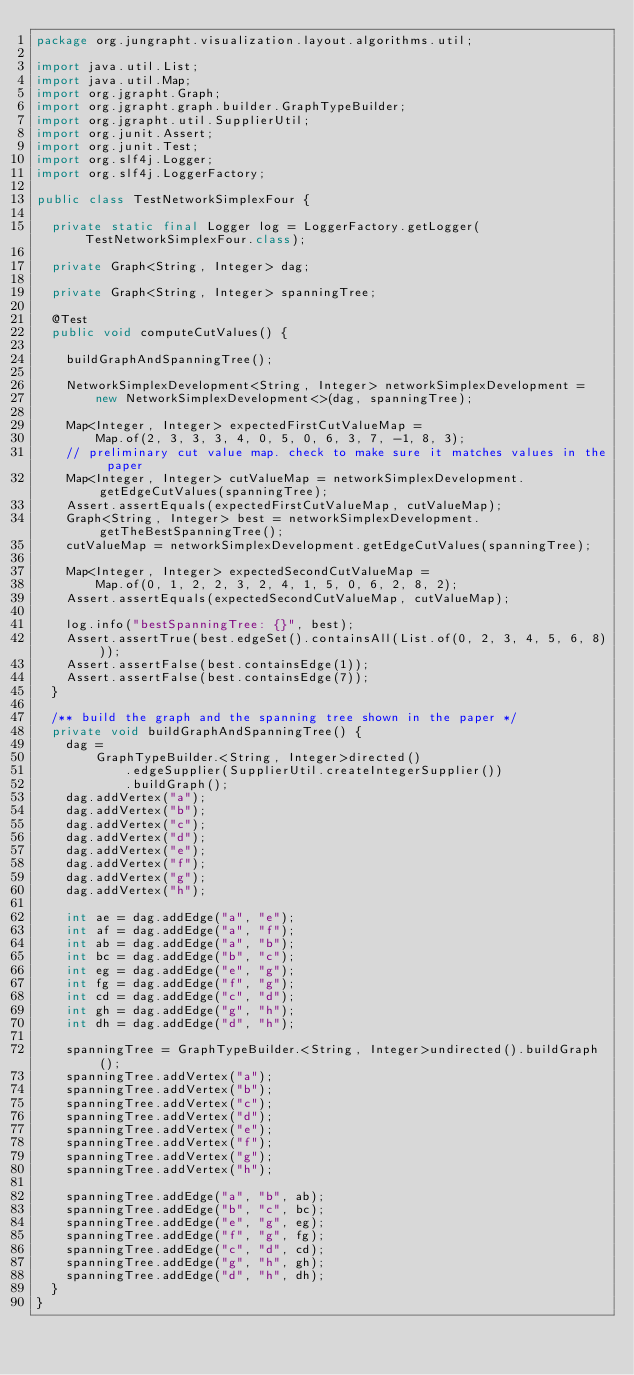Convert code to text. <code><loc_0><loc_0><loc_500><loc_500><_Java_>package org.jungrapht.visualization.layout.algorithms.util;

import java.util.List;
import java.util.Map;
import org.jgrapht.Graph;
import org.jgrapht.graph.builder.GraphTypeBuilder;
import org.jgrapht.util.SupplierUtil;
import org.junit.Assert;
import org.junit.Test;
import org.slf4j.Logger;
import org.slf4j.LoggerFactory;

public class TestNetworkSimplexFour {

  private static final Logger log = LoggerFactory.getLogger(TestNetworkSimplexFour.class);

  private Graph<String, Integer> dag;

  private Graph<String, Integer> spanningTree;

  @Test
  public void computeCutValues() {

    buildGraphAndSpanningTree();

    NetworkSimplexDevelopment<String, Integer> networkSimplexDevelopment =
        new NetworkSimplexDevelopment<>(dag, spanningTree);

    Map<Integer, Integer> expectedFirstCutValueMap =
        Map.of(2, 3, 3, 3, 4, 0, 5, 0, 6, 3, 7, -1, 8, 3);
    // preliminary cut value map. check to make sure it matches values in the paper
    Map<Integer, Integer> cutValueMap = networkSimplexDevelopment.getEdgeCutValues(spanningTree);
    Assert.assertEquals(expectedFirstCutValueMap, cutValueMap);
    Graph<String, Integer> best = networkSimplexDevelopment.getTheBestSpanningTree();
    cutValueMap = networkSimplexDevelopment.getEdgeCutValues(spanningTree);

    Map<Integer, Integer> expectedSecondCutValueMap =
        Map.of(0, 1, 2, 2, 3, 2, 4, 1, 5, 0, 6, 2, 8, 2);
    Assert.assertEquals(expectedSecondCutValueMap, cutValueMap);

    log.info("bestSpanningTree: {}", best);
    Assert.assertTrue(best.edgeSet().containsAll(List.of(0, 2, 3, 4, 5, 6, 8)));
    Assert.assertFalse(best.containsEdge(1));
    Assert.assertFalse(best.containsEdge(7));
  }

  /** build the graph and the spanning tree shown in the paper */
  private void buildGraphAndSpanningTree() {
    dag =
        GraphTypeBuilder.<String, Integer>directed()
            .edgeSupplier(SupplierUtil.createIntegerSupplier())
            .buildGraph();
    dag.addVertex("a");
    dag.addVertex("b");
    dag.addVertex("c");
    dag.addVertex("d");
    dag.addVertex("e");
    dag.addVertex("f");
    dag.addVertex("g");
    dag.addVertex("h");

    int ae = dag.addEdge("a", "e");
    int af = dag.addEdge("a", "f");
    int ab = dag.addEdge("a", "b");
    int bc = dag.addEdge("b", "c");
    int eg = dag.addEdge("e", "g");
    int fg = dag.addEdge("f", "g");
    int cd = dag.addEdge("c", "d");
    int gh = dag.addEdge("g", "h");
    int dh = dag.addEdge("d", "h");

    spanningTree = GraphTypeBuilder.<String, Integer>undirected().buildGraph();
    spanningTree.addVertex("a");
    spanningTree.addVertex("b");
    spanningTree.addVertex("c");
    spanningTree.addVertex("d");
    spanningTree.addVertex("e");
    spanningTree.addVertex("f");
    spanningTree.addVertex("g");
    spanningTree.addVertex("h");

    spanningTree.addEdge("a", "b", ab);
    spanningTree.addEdge("b", "c", bc);
    spanningTree.addEdge("e", "g", eg);
    spanningTree.addEdge("f", "g", fg);
    spanningTree.addEdge("c", "d", cd);
    spanningTree.addEdge("g", "h", gh);
    spanningTree.addEdge("d", "h", dh);
  }
}
</code> 